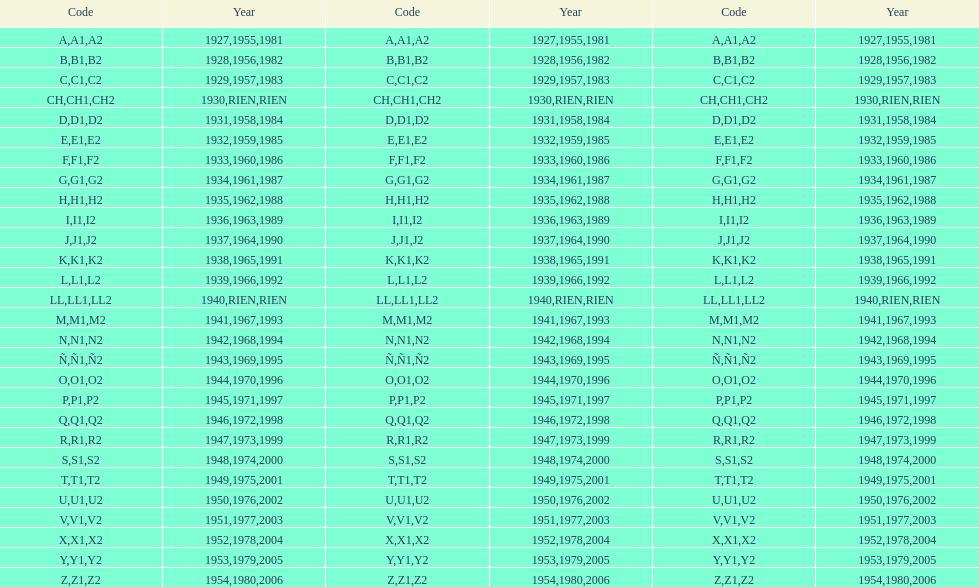When was the smallest year printed on a stamp? 1927. 